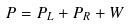Convert formula to latex. <formula><loc_0><loc_0><loc_500><loc_500>P = P _ { L } + P _ { R } + W</formula> 